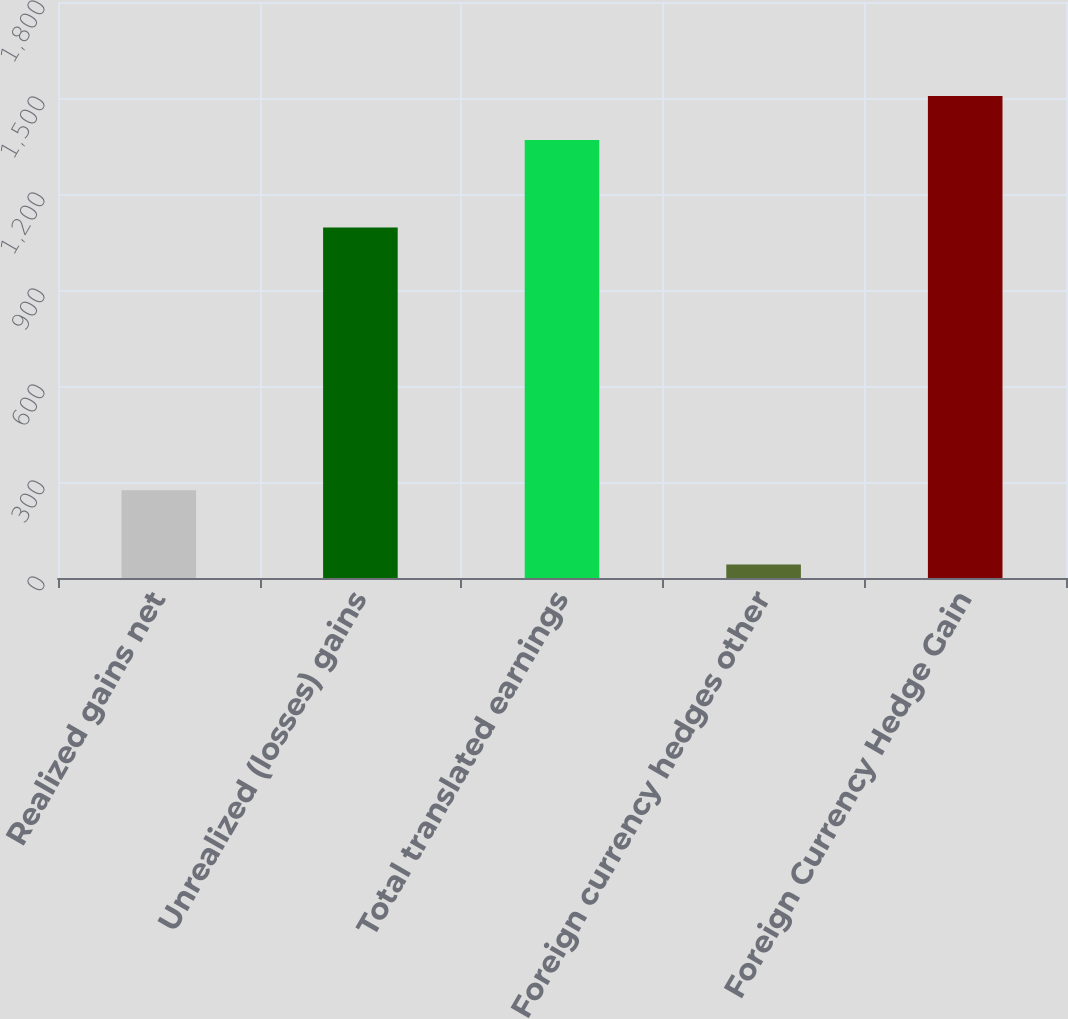Convert chart to OTSL. <chart><loc_0><loc_0><loc_500><loc_500><bar_chart><fcel>Realized gains net<fcel>Unrealized (losses) gains<fcel>Total translated earnings<fcel>Foreign currency hedges other<fcel>Foreign Currency Hedge Gain<nl><fcel>274<fcel>1095<fcel>1369<fcel>42<fcel>1505.9<nl></chart> 